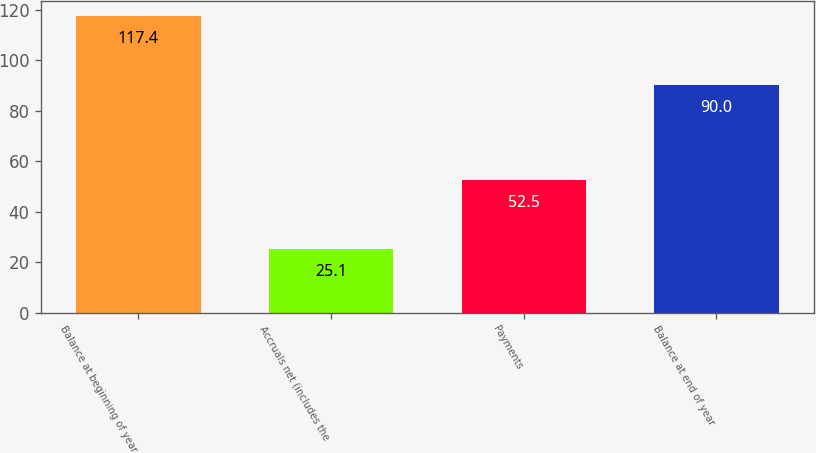Convert chart to OTSL. <chart><loc_0><loc_0><loc_500><loc_500><bar_chart><fcel>Balance at beginning of year<fcel>Accruals net (includes the<fcel>Payments<fcel>Balance at end of year<nl><fcel>117.4<fcel>25.1<fcel>52.5<fcel>90<nl></chart> 